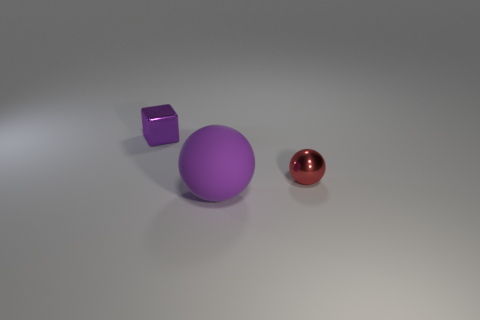Add 3 tiny red balls. How many objects exist? 6 Subtract all spheres. How many objects are left? 1 Add 3 purple metal cylinders. How many purple metal cylinders exist? 3 Subtract 1 purple balls. How many objects are left? 2 Subtract all tiny red matte balls. Subtract all small balls. How many objects are left? 2 Add 3 tiny metal cubes. How many tiny metal cubes are left? 4 